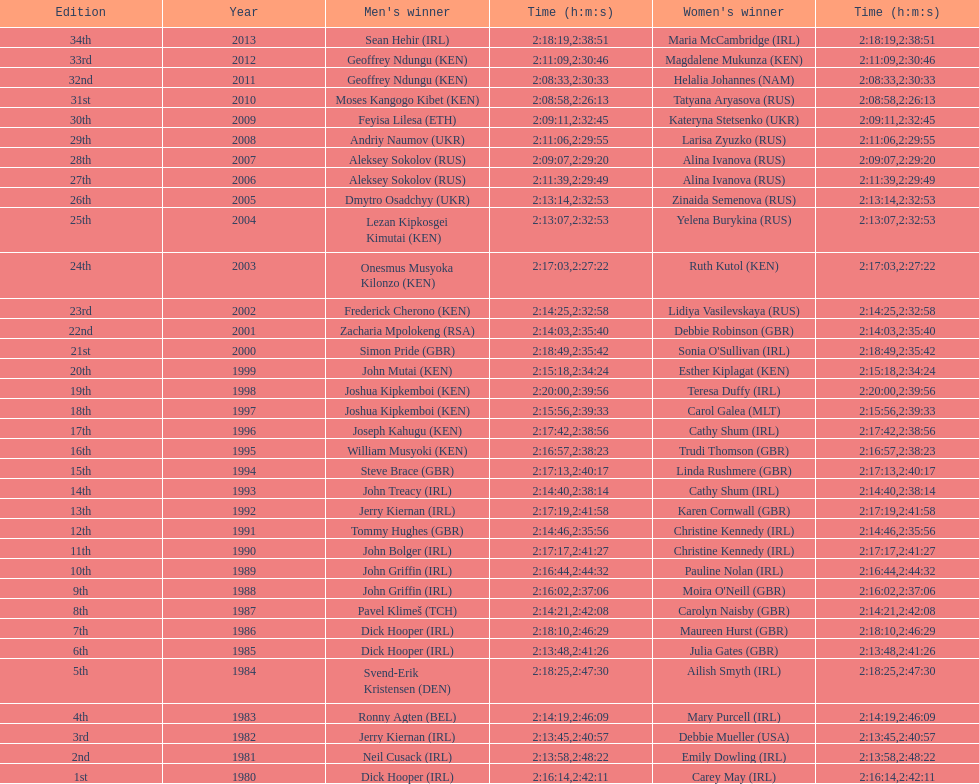Who won at least 3 times in the mens? Dick Hooper (IRL). 